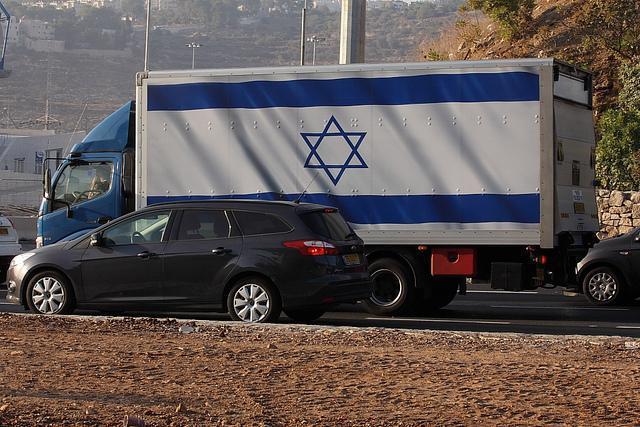How many cars are there?
Give a very brief answer. 2. 